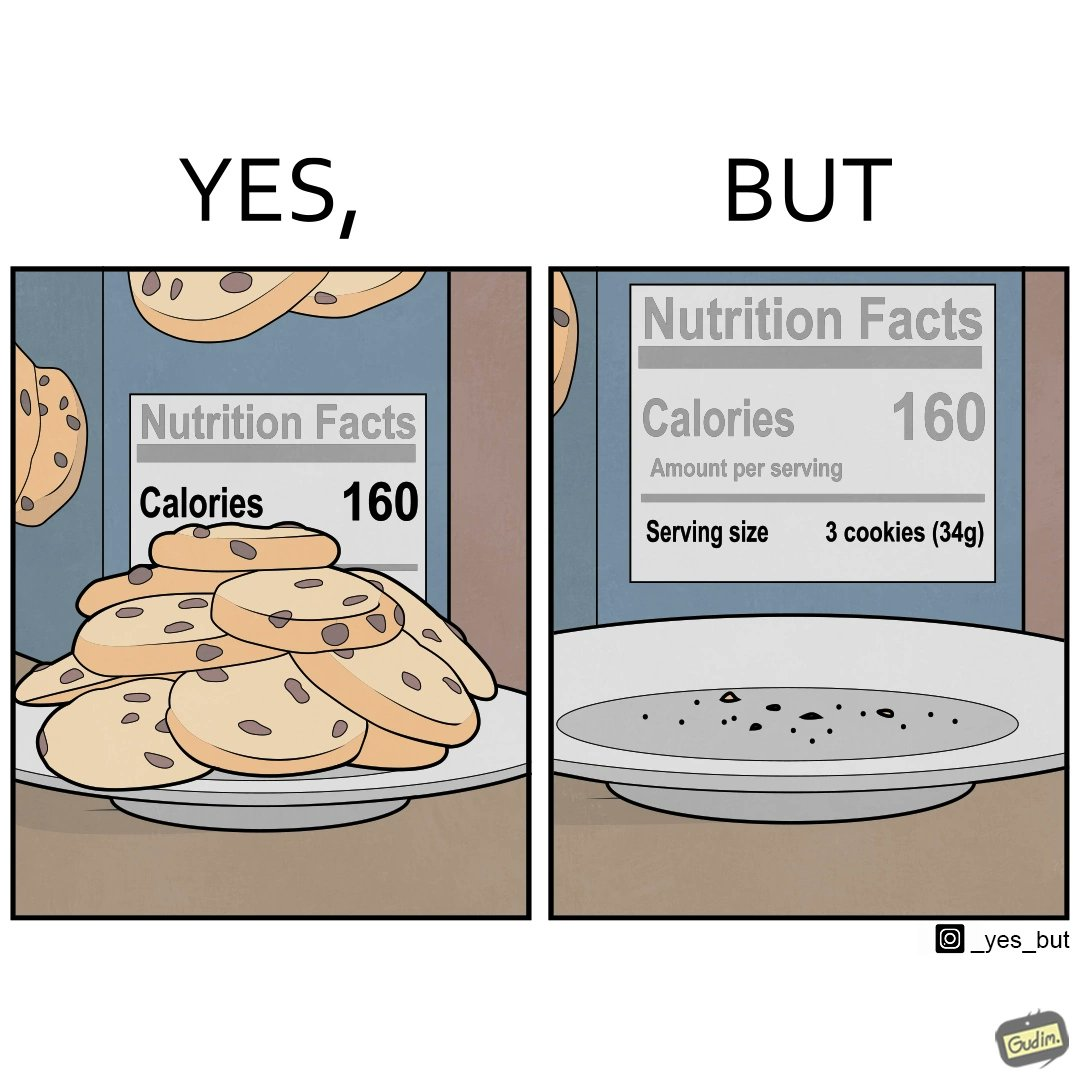Is this image satirical or non-satirical? Yes, this image is satirical. 